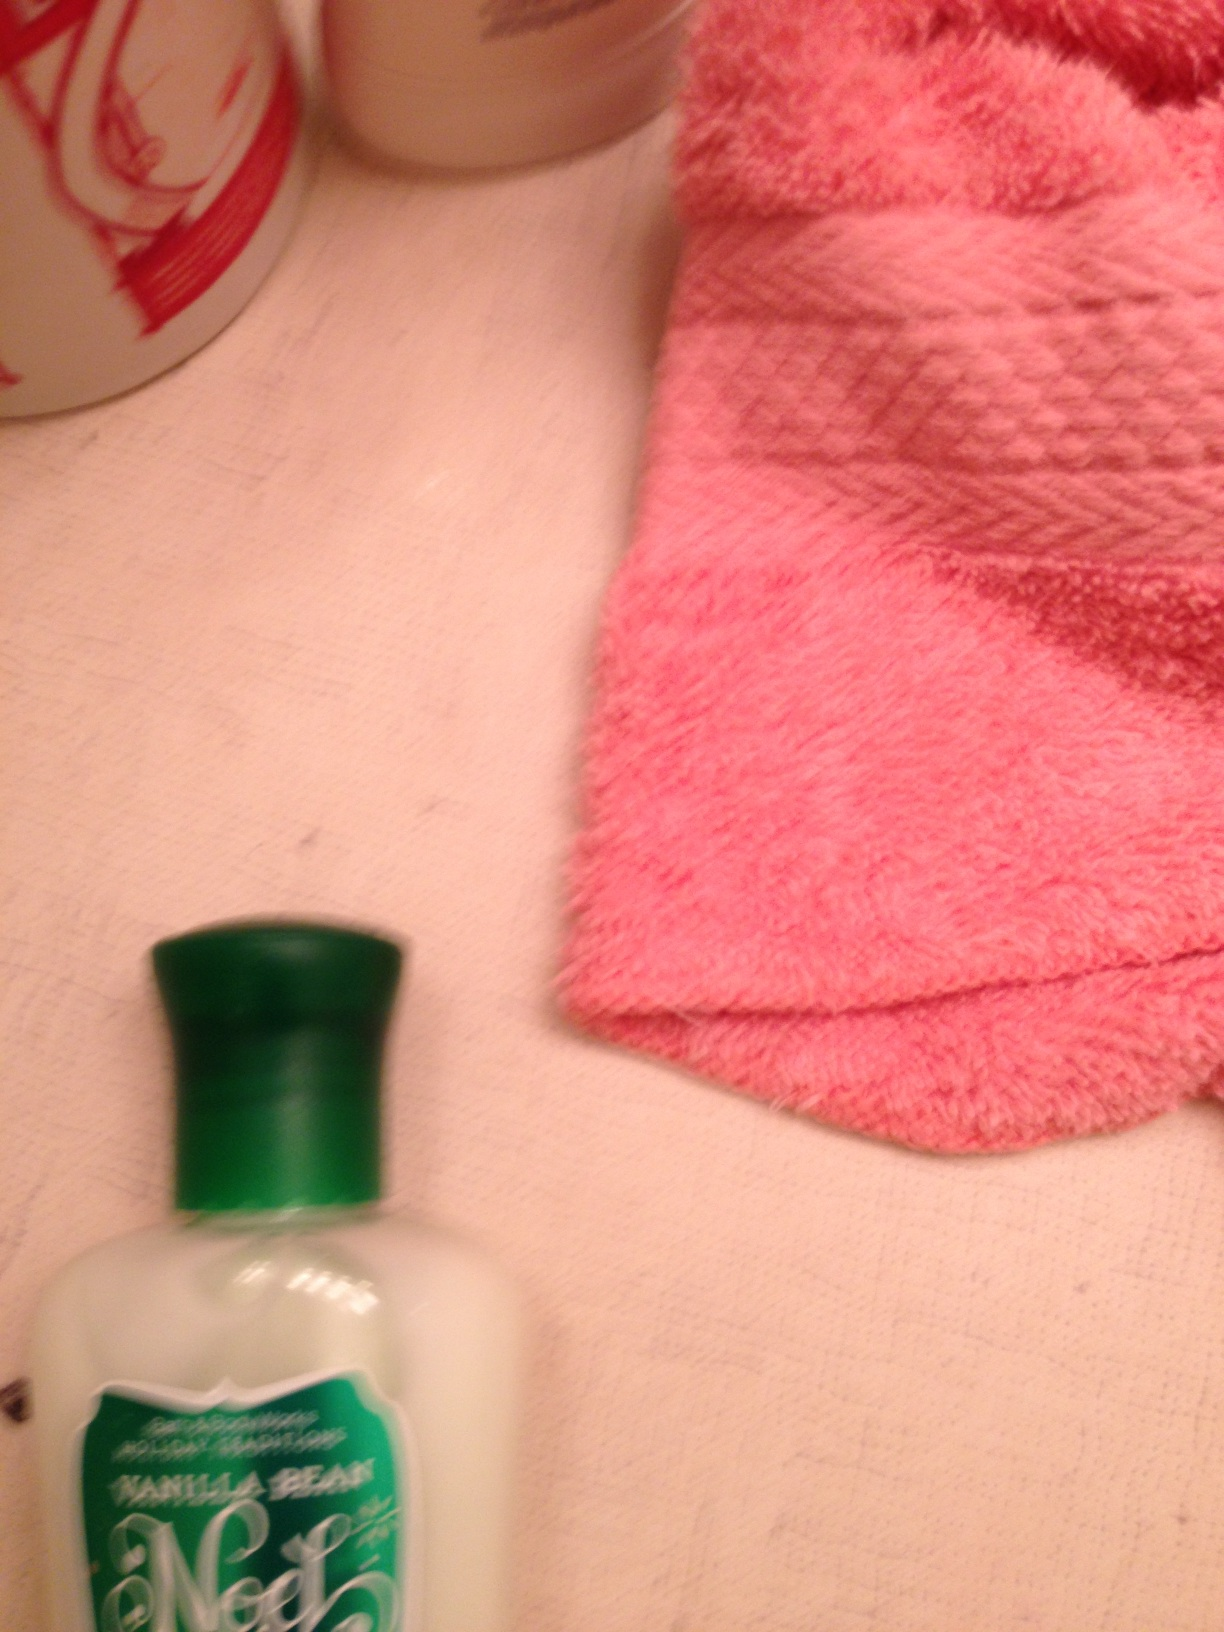Can you describe the items shown in the image? Certainly! The image shows a bottle of 'Vanilla Bean Noel' lotion with a green cap, a pink textured towel, and parts of other bottles, likely containing toiletries. The setting seems to be a bathroom or a personal care area. What is the use of the pink towel? The pink towel is likely used for drying hands or face. Its texture suggests it's absorbent and soft, making it suitable for personal hygiene purposes. 